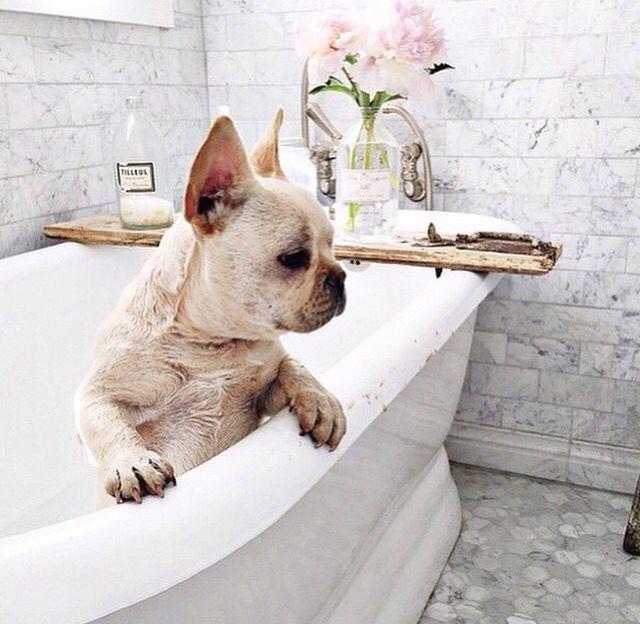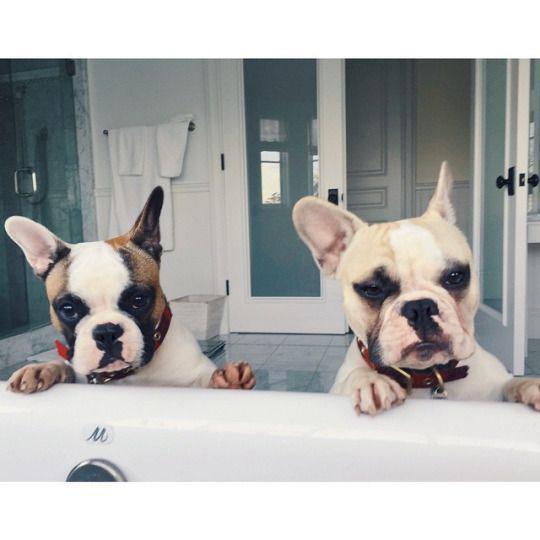The first image is the image on the left, the second image is the image on the right. Analyze the images presented: Is the assertion "In the left image, one white bulldog is alone in a white tub and has its front paws on the rim of the tub." valid? Answer yes or no. Yes. 